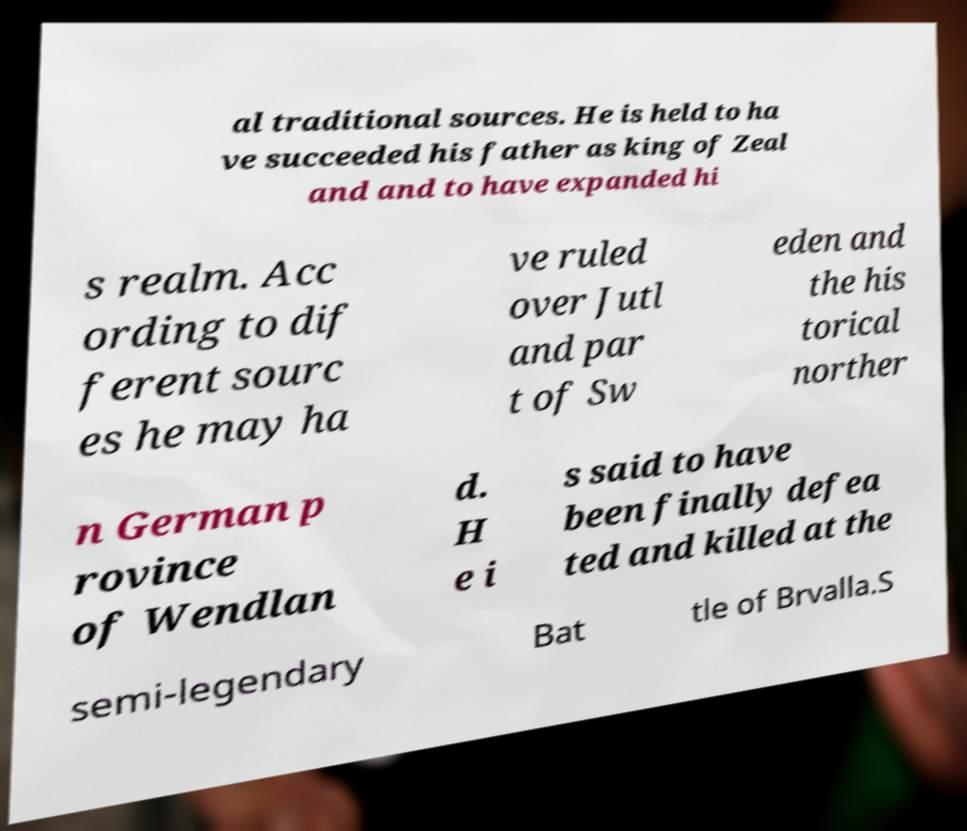Could you extract and type out the text from this image? al traditional sources. He is held to ha ve succeeded his father as king of Zeal and and to have expanded hi s realm. Acc ording to dif ferent sourc es he may ha ve ruled over Jutl and par t of Sw eden and the his torical norther n German p rovince of Wendlan d. H e i s said to have been finally defea ted and killed at the semi-legendary Bat tle of Brvalla.S 